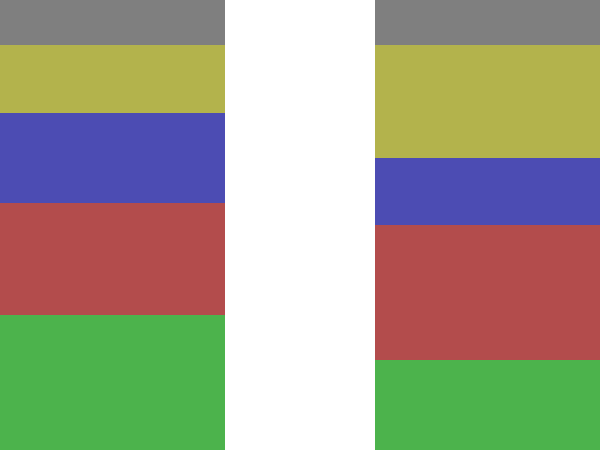Based on the stacked bar chart comparing the sectoral composition of GDP pre- and post-sanctions, which sector experienced the most significant percentage point increase after the implementation of sanctions? To determine which sector experienced the most significant percentage point increase after sanctions, we need to compare the pre- and post-sanction values for each sector:

1. Agriculture:
   Pre-sanctions: 30%
   Post-sanctions: 20%
   Change: -10 percentage points

2. Manufacturing:
   Pre-sanctions: 25%
   Post-sanctions: 30%
   Change: +5 percentage points

3. Services:
   Pre-sanctions: 20%
   Post-sanctions: 15%
   Change: -5 percentage points

4. Energy:
   Pre-sanctions: 15%
   Post-sanctions: 25%
   Change: +10 percentage points

5. Other:
   Pre-sanctions: 10%
   Post-sanctions: 10%
   Change: 0 percentage points

The sector with the most significant percentage point increase is Energy, with a 10 percentage point increase from 15% to 25%.
Answer: Energy sector 